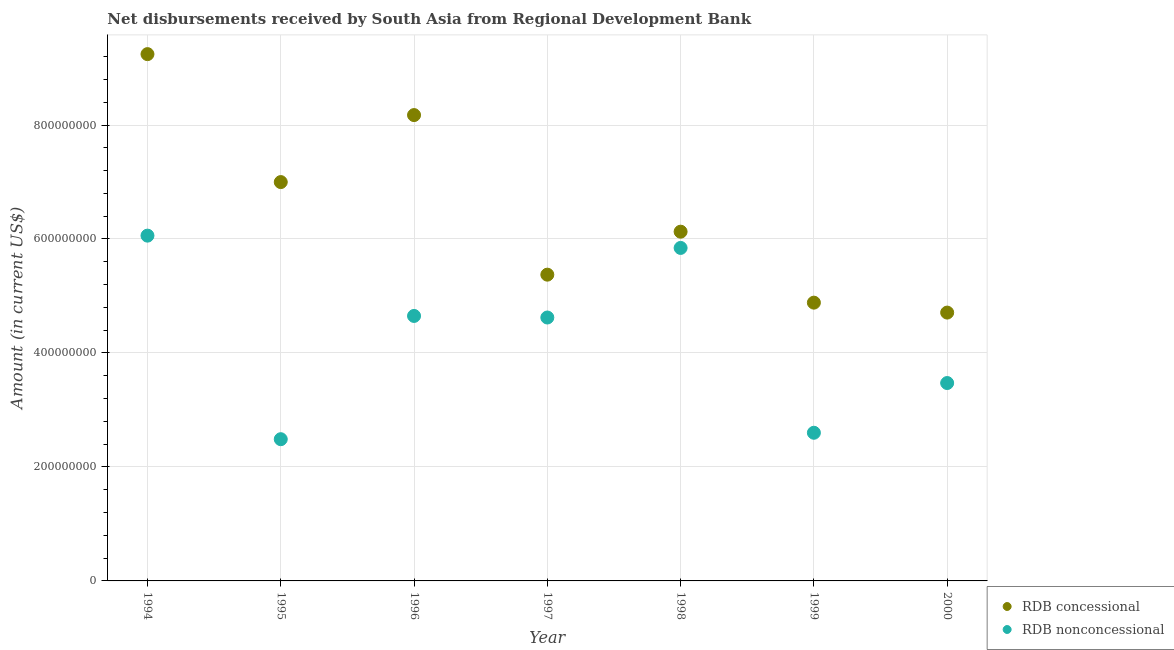How many different coloured dotlines are there?
Ensure brevity in your answer.  2. Is the number of dotlines equal to the number of legend labels?
Make the answer very short. Yes. What is the net non concessional disbursements from rdb in 1999?
Give a very brief answer. 2.60e+08. Across all years, what is the maximum net non concessional disbursements from rdb?
Your response must be concise. 6.06e+08. Across all years, what is the minimum net non concessional disbursements from rdb?
Your response must be concise. 2.49e+08. In which year was the net concessional disbursements from rdb minimum?
Offer a very short reply. 2000. What is the total net non concessional disbursements from rdb in the graph?
Ensure brevity in your answer.  2.97e+09. What is the difference between the net concessional disbursements from rdb in 1994 and that in 1995?
Offer a terse response. 2.25e+08. What is the difference between the net concessional disbursements from rdb in 1997 and the net non concessional disbursements from rdb in 1998?
Ensure brevity in your answer.  -4.69e+07. What is the average net concessional disbursements from rdb per year?
Give a very brief answer. 6.50e+08. In the year 2000, what is the difference between the net concessional disbursements from rdb and net non concessional disbursements from rdb?
Provide a succinct answer. 1.24e+08. In how many years, is the net non concessional disbursements from rdb greater than 80000000 US$?
Offer a very short reply. 7. What is the ratio of the net non concessional disbursements from rdb in 1994 to that in 1995?
Keep it short and to the point. 2.44. What is the difference between the highest and the second highest net concessional disbursements from rdb?
Provide a short and direct response. 1.07e+08. What is the difference between the highest and the lowest net concessional disbursements from rdb?
Offer a very short reply. 4.54e+08. In how many years, is the net non concessional disbursements from rdb greater than the average net non concessional disbursements from rdb taken over all years?
Ensure brevity in your answer.  4. Does the net concessional disbursements from rdb monotonically increase over the years?
Your response must be concise. No. What is the difference between two consecutive major ticks on the Y-axis?
Make the answer very short. 2.00e+08. Does the graph contain grids?
Ensure brevity in your answer.  Yes. How are the legend labels stacked?
Ensure brevity in your answer.  Vertical. What is the title of the graph?
Provide a short and direct response. Net disbursements received by South Asia from Regional Development Bank. What is the label or title of the X-axis?
Your answer should be very brief. Year. What is the label or title of the Y-axis?
Keep it short and to the point. Amount (in current US$). What is the Amount (in current US$) in RDB concessional in 1994?
Ensure brevity in your answer.  9.24e+08. What is the Amount (in current US$) of RDB nonconcessional in 1994?
Offer a terse response. 6.06e+08. What is the Amount (in current US$) in RDB concessional in 1995?
Your answer should be very brief. 7.00e+08. What is the Amount (in current US$) of RDB nonconcessional in 1995?
Give a very brief answer. 2.49e+08. What is the Amount (in current US$) in RDB concessional in 1996?
Your response must be concise. 8.17e+08. What is the Amount (in current US$) of RDB nonconcessional in 1996?
Keep it short and to the point. 4.65e+08. What is the Amount (in current US$) of RDB concessional in 1997?
Keep it short and to the point. 5.37e+08. What is the Amount (in current US$) in RDB nonconcessional in 1997?
Provide a short and direct response. 4.62e+08. What is the Amount (in current US$) of RDB concessional in 1998?
Your answer should be very brief. 6.13e+08. What is the Amount (in current US$) in RDB nonconcessional in 1998?
Ensure brevity in your answer.  5.84e+08. What is the Amount (in current US$) in RDB concessional in 1999?
Ensure brevity in your answer.  4.88e+08. What is the Amount (in current US$) of RDB nonconcessional in 1999?
Your answer should be very brief. 2.60e+08. What is the Amount (in current US$) in RDB concessional in 2000?
Give a very brief answer. 4.71e+08. What is the Amount (in current US$) of RDB nonconcessional in 2000?
Offer a very short reply. 3.47e+08. Across all years, what is the maximum Amount (in current US$) of RDB concessional?
Provide a succinct answer. 9.24e+08. Across all years, what is the maximum Amount (in current US$) of RDB nonconcessional?
Provide a short and direct response. 6.06e+08. Across all years, what is the minimum Amount (in current US$) in RDB concessional?
Your answer should be compact. 4.71e+08. Across all years, what is the minimum Amount (in current US$) in RDB nonconcessional?
Offer a very short reply. 2.49e+08. What is the total Amount (in current US$) of RDB concessional in the graph?
Offer a terse response. 4.55e+09. What is the total Amount (in current US$) in RDB nonconcessional in the graph?
Offer a very short reply. 2.97e+09. What is the difference between the Amount (in current US$) in RDB concessional in 1994 and that in 1995?
Your response must be concise. 2.25e+08. What is the difference between the Amount (in current US$) in RDB nonconcessional in 1994 and that in 1995?
Make the answer very short. 3.57e+08. What is the difference between the Amount (in current US$) in RDB concessional in 1994 and that in 1996?
Provide a short and direct response. 1.07e+08. What is the difference between the Amount (in current US$) of RDB nonconcessional in 1994 and that in 1996?
Offer a terse response. 1.41e+08. What is the difference between the Amount (in current US$) of RDB concessional in 1994 and that in 1997?
Ensure brevity in your answer.  3.87e+08. What is the difference between the Amount (in current US$) in RDB nonconcessional in 1994 and that in 1997?
Offer a very short reply. 1.44e+08. What is the difference between the Amount (in current US$) in RDB concessional in 1994 and that in 1998?
Your answer should be very brief. 3.12e+08. What is the difference between the Amount (in current US$) in RDB nonconcessional in 1994 and that in 1998?
Your answer should be very brief. 2.16e+07. What is the difference between the Amount (in current US$) in RDB concessional in 1994 and that in 1999?
Your answer should be very brief. 4.36e+08. What is the difference between the Amount (in current US$) of RDB nonconcessional in 1994 and that in 1999?
Provide a succinct answer. 3.46e+08. What is the difference between the Amount (in current US$) in RDB concessional in 1994 and that in 2000?
Your response must be concise. 4.54e+08. What is the difference between the Amount (in current US$) in RDB nonconcessional in 1994 and that in 2000?
Offer a terse response. 2.59e+08. What is the difference between the Amount (in current US$) in RDB concessional in 1995 and that in 1996?
Ensure brevity in your answer.  -1.18e+08. What is the difference between the Amount (in current US$) of RDB nonconcessional in 1995 and that in 1996?
Keep it short and to the point. -2.16e+08. What is the difference between the Amount (in current US$) in RDB concessional in 1995 and that in 1997?
Offer a very short reply. 1.62e+08. What is the difference between the Amount (in current US$) in RDB nonconcessional in 1995 and that in 1997?
Give a very brief answer. -2.14e+08. What is the difference between the Amount (in current US$) in RDB concessional in 1995 and that in 1998?
Your response must be concise. 8.70e+07. What is the difference between the Amount (in current US$) of RDB nonconcessional in 1995 and that in 1998?
Make the answer very short. -3.36e+08. What is the difference between the Amount (in current US$) of RDB concessional in 1995 and that in 1999?
Give a very brief answer. 2.12e+08. What is the difference between the Amount (in current US$) in RDB nonconcessional in 1995 and that in 1999?
Provide a succinct answer. -1.13e+07. What is the difference between the Amount (in current US$) in RDB concessional in 1995 and that in 2000?
Offer a very short reply. 2.29e+08. What is the difference between the Amount (in current US$) of RDB nonconcessional in 1995 and that in 2000?
Your answer should be compact. -9.86e+07. What is the difference between the Amount (in current US$) of RDB concessional in 1996 and that in 1997?
Provide a short and direct response. 2.80e+08. What is the difference between the Amount (in current US$) of RDB nonconcessional in 1996 and that in 1997?
Keep it short and to the point. 2.76e+06. What is the difference between the Amount (in current US$) in RDB concessional in 1996 and that in 1998?
Your answer should be compact. 2.05e+08. What is the difference between the Amount (in current US$) of RDB nonconcessional in 1996 and that in 1998?
Your answer should be very brief. -1.19e+08. What is the difference between the Amount (in current US$) of RDB concessional in 1996 and that in 1999?
Your response must be concise. 3.29e+08. What is the difference between the Amount (in current US$) in RDB nonconcessional in 1996 and that in 1999?
Keep it short and to the point. 2.05e+08. What is the difference between the Amount (in current US$) of RDB concessional in 1996 and that in 2000?
Ensure brevity in your answer.  3.47e+08. What is the difference between the Amount (in current US$) in RDB nonconcessional in 1996 and that in 2000?
Make the answer very short. 1.18e+08. What is the difference between the Amount (in current US$) in RDB concessional in 1997 and that in 1998?
Your answer should be very brief. -7.54e+07. What is the difference between the Amount (in current US$) in RDB nonconcessional in 1997 and that in 1998?
Give a very brief answer. -1.22e+08. What is the difference between the Amount (in current US$) in RDB concessional in 1997 and that in 1999?
Offer a terse response. 4.91e+07. What is the difference between the Amount (in current US$) in RDB nonconcessional in 1997 and that in 1999?
Your answer should be very brief. 2.02e+08. What is the difference between the Amount (in current US$) of RDB concessional in 1997 and that in 2000?
Offer a very short reply. 6.66e+07. What is the difference between the Amount (in current US$) in RDB nonconcessional in 1997 and that in 2000?
Your response must be concise. 1.15e+08. What is the difference between the Amount (in current US$) in RDB concessional in 1998 and that in 1999?
Your answer should be very brief. 1.25e+08. What is the difference between the Amount (in current US$) of RDB nonconcessional in 1998 and that in 1999?
Provide a succinct answer. 3.24e+08. What is the difference between the Amount (in current US$) of RDB concessional in 1998 and that in 2000?
Provide a succinct answer. 1.42e+08. What is the difference between the Amount (in current US$) of RDB nonconcessional in 1998 and that in 2000?
Offer a terse response. 2.37e+08. What is the difference between the Amount (in current US$) of RDB concessional in 1999 and that in 2000?
Provide a succinct answer. 1.75e+07. What is the difference between the Amount (in current US$) in RDB nonconcessional in 1999 and that in 2000?
Offer a terse response. -8.73e+07. What is the difference between the Amount (in current US$) in RDB concessional in 1994 and the Amount (in current US$) in RDB nonconcessional in 1995?
Your answer should be compact. 6.76e+08. What is the difference between the Amount (in current US$) of RDB concessional in 1994 and the Amount (in current US$) of RDB nonconcessional in 1996?
Provide a succinct answer. 4.59e+08. What is the difference between the Amount (in current US$) of RDB concessional in 1994 and the Amount (in current US$) of RDB nonconcessional in 1997?
Ensure brevity in your answer.  4.62e+08. What is the difference between the Amount (in current US$) of RDB concessional in 1994 and the Amount (in current US$) of RDB nonconcessional in 1998?
Give a very brief answer. 3.40e+08. What is the difference between the Amount (in current US$) in RDB concessional in 1994 and the Amount (in current US$) in RDB nonconcessional in 1999?
Keep it short and to the point. 6.64e+08. What is the difference between the Amount (in current US$) of RDB concessional in 1994 and the Amount (in current US$) of RDB nonconcessional in 2000?
Make the answer very short. 5.77e+08. What is the difference between the Amount (in current US$) of RDB concessional in 1995 and the Amount (in current US$) of RDB nonconcessional in 1996?
Give a very brief answer. 2.35e+08. What is the difference between the Amount (in current US$) of RDB concessional in 1995 and the Amount (in current US$) of RDB nonconcessional in 1997?
Offer a very short reply. 2.38e+08. What is the difference between the Amount (in current US$) of RDB concessional in 1995 and the Amount (in current US$) of RDB nonconcessional in 1998?
Make the answer very short. 1.16e+08. What is the difference between the Amount (in current US$) of RDB concessional in 1995 and the Amount (in current US$) of RDB nonconcessional in 1999?
Provide a short and direct response. 4.40e+08. What is the difference between the Amount (in current US$) of RDB concessional in 1995 and the Amount (in current US$) of RDB nonconcessional in 2000?
Offer a terse response. 3.53e+08. What is the difference between the Amount (in current US$) of RDB concessional in 1996 and the Amount (in current US$) of RDB nonconcessional in 1997?
Offer a very short reply. 3.55e+08. What is the difference between the Amount (in current US$) in RDB concessional in 1996 and the Amount (in current US$) in RDB nonconcessional in 1998?
Provide a short and direct response. 2.33e+08. What is the difference between the Amount (in current US$) of RDB concessional in 1996 and the Amount (in current US$) of RDB nonconcessional in 1999?
Give a very brief answer. 5.57e+08. What is the difference between the Amount (in current US$) in RDB concessional in 1996 and the Amount (in current US$) in RDB nonconcessional in 2000?
Make the answer very short. 4.70e+08. What is the difference between the Amount (in current US$) of RDB concessional in 1997 and the Amount (in current US$) of RDB nonconcessional in 1998?
Provide a short and direct response. -4.69e+07. What is the difference between the Amount (in current US$) of RDB concessional in 1997 and the Amount (in current US$) of RDB nonconcessional in 1999?
Give a very brief answer. 2.77e+08. What is the difference between the Amount (in current US$) of RDB concessional in 1997 and the Amount (in current US$) of RDB nonconcessional in 2000?
Your response must be concise. 1.90e+08. What is the difference between the Amount (in current US$) in RDB concessional in 1998 and the Amount (in current US$) in RDB nonconcessional in 1999?
Provide a succinct answer. 3.53e+08. What is the difference between the Amount (in current US$) in RDB concessional in 1998 and the Amount (in current US$) in RDB nonconcessional in 2000?
Keep it short and to the point. 2.66e+08. What is the difference between the Amount (in current US$) in RDB concessional in 1999 and the Amount (in current US$) in RDB nonconcessional in 2000?
Ensure brevity in your answer.  1.41e+08. What is the average Amount (in current US$) in RDB concessional per year?
Make the answer very short. 6.50e+08. What is the average Amount (in current US$) in RDB nonconcessional per year?
Ensure brevity in your answer.  4.25e+08. In the year 1994, what is the difference between the Amount (in current US$) in RDB concessional and Amount (in current US$) in RDB nonconcessional?
Provide a short and direct response. 3.19e+08. In the year 1995, what is the difference between the Amount (in current US$) of RDB concessional and Amount (in current US$) of RDB nonconcessional?
Your answer should be compact. 4.51e+08. In the year 1996, what is the difference between the Amount (in current US$) in RDB concessional and Amount (in current US$) in RDB nonconcessional?
Ensure brevity in your answer.  3.52e+08. In the year 1997, what is the difference between the Amount (in current US$) of RDB concessional and Amount (in current US$) of RDB nonconcessional?
Your response must be concise. 7.52e+07. In the year 1998, what is the difference between the Amount (in current US$) in RDB concessional and Amount (in current US$) in RDB nonconcessional?
Provide a short and direct response. 2.85e+07. In the year 1999, what is the difference between the Amount (in current US$) in RDB concessional and Amount (in current US$) in RDB nonconcessional?
Offer a very short reply. 2.28e+08. In the year 2000, what is the difference between the Amount (in current US$) of RDB concessional and Amount (in current US$) of RDB nonconcessional?
Provide a short and direct response. 1.24e+08. What is the ratio of the Amount (in current US$) of RDB concessional in 1994 to that in 1995?
Provide a short and direct response. 1.32. What is the ratio of the Amount (in current US$) of RDB nonconcessional in 1994 to that in 1995?
Provide a succinct answer. 2.44. What is the ratio of the Amount (in current US$) of RDB concessional in 1994 to that in 1996?
Ensure brevity in your answer.  1.13. What is the ratio of the Amount (in current US$) in RDB nonconcessional in 1994 to that in 1996?
Your answer should be very brief. 1.3. What is the ratio of the Amount (in current US$) in RDB concessional in 1994 to that in 1997?
Keep it short and to the point. 1.72. What is the ratio of the Amount (in current US$) in RDB nonconcessional in 1994 to that in 1997?
Make the answer very short. 1.31. What is the ratio of the Amount (in current US$) in RDB concessional in 1994 to that in 1998?
Your answer should be very brief. 1.51. What is the ratio of the Amount (in current US$) of RDB nonconcessional in 1994 to that in 1998?
Give a very brief answer. 1.04. What is the ratio of the Amount (in current US$) in RDB concessional in 1994 to that in 1999?
Your response must be concise. 1.89. What is the ratio of the Amount (in current US$) of RDB nonconcessional in 1994 to that in 1999?
Your answer should be compact. 2.33. What is the ratio of the Amount (in current US$) of RDB concessional in 1994 to that in 2000?
Offer a very short reply. 1.96. What is the ratio of the Amount (in current US$) of RDB nonconcessional in 1994 to that in 2000?
Provide a short and direct response. 1.74. What is the ratio of the Amount (in current US$) of RDB concessional in 1995 to that in 1996?
Your answer should be very brief. 0.86. What is the ratio of the Amount (in current US$) of RDB nonconcessional in 1995 to that in 1996?
Keep it short and to the point. 0.53. What is the ratio of the Amount (in current US$) of RDB concessional in 1995 to that in 1997?
Offer a very short reply. 1.3. What is the ratio of the Amount (in current US$) in RDB nonconcessional in 1995 to that in 1997?
Keep it short and to the point. 0.54. What is the ratio of the Amount (in current US$) in RDB concessional in 1995 to that in 1998?
Keep it short and to the point. 1.14. What is the ratio of the Amount (in current US$) of RDB nonconcessional in 1995 to that in 1998?
Offer a very short reply. 0.43. What is the ratio of the Amount (in current US$) of RDB concessional in 1995 to that in 1999?
Keep it short and to the point. 1.43. What is the ratio of the Amount (in current US$) of RDB nonconcessional in 1995 to that in 1999?
Provide a short and direct response. 0.96. What is the ratio of the Amount (in current US$) in RDB concessional in 1995 to that in 2000?
Provide a short and direct response. 1.49. What is the ratio of the Amount (in current US$) in RDB nonconcessional in 1995 to that in 2000?
Offer a terse response. 0.72. What is the ratio of the Amount (in current US$) of RDB concessional in 1996 to that in 1997?
Offer a very short reply. 1.52. What is the ratio of the Amount (in current US$) in RDB concessional in 1996 to that in 1998?
Provide a short and direct response. 1.33. What is the ratio of the Amount (in current US$) of RDB nonconcessional in 1996 to that in 1998?
Provide a short and direct response. 0.8. What is the ratio of the Amount (in current US$) of RDB concessional in 1996 to that in 1999?
Provide a succinct answer. 1.67. What is the ratio of the Amount (in current US$) in RDB nonconcessional in 1996 to that in 1999?
Keep it short and to the point. 1.79. What is the ratio of the Amount (in current US$) of RDB concessional in 1996 to that in 2000?
Your answer should be compact. 1.74. What is the ratio of the Amount (in current US$) of RDB nonconcessional in 1996 to that in 2000?
Provide a succinct answer. 1.34. What is the ratio of the Amount (in current US$) of RDB concessional in 1997 to that in 1998?
Offer a terse response. 0.88. What is the ratio of the Amount (in current US$) of RDB nonconcessional in 1997 to that in 1998?
Your answer should be very brief. 0.79. What is the ratio of the Amount (in current US$) in RDB concessional in 1997 to that in 1999?
Offer a terse response. 1.1. What is the ratio of the Amount (in current US$) of RDB nonconcessional in 1997 to that in 1999?
Give a very brief answer. 1.78. What is the ratio of the Amount (in current US$) in RDB concessional in 1997 to that in 2000?
Give a very brief answer. 1.14. What is the ratio of the Amount (in current US$) in RDB nonconcessional in 1997 to that in 2000?
Your answer should be very brief. 1.33. What is the ratio of the Amount (in current US$) in RDB concessional in 1998 to that in 1999?
Ensure brevity in your answer.  1.25. What is the ratio of the Amount (in current US$) of RDB nonconcessional in 1998 to that in 1999?
Make the answer very short. 2.25. What is the ratio of the Amount (in current US$) in RDB concessional in 1998 to that in 2000?
Ensure brevity in your answer.  1.3. What is the ratio of the Amount (in current US$) of RDB nonconcessional in 1998 to that in 2000?
Your response must be concise. 1.68. What is the ratio of the Amount (in current US$) of RDB concessional in 1999 to that in 2000?
Provide a short and direct response. 1.04. What is the ratio of the Amount (in current US$) in RDB nonconcessional in 1999 to that in 2000?
Make the answer very short. 0.75. What is the difference between the highest and the second highest Amount (in current US$) of RDB concessional?
Make the answer very short. 1.07e+08. What is the difference between the highest and the second highest Amount (in current US$) of RDB nonconcessional?
Give a very brief answer. 2.16e+07. What is the difference between the highest and the lowest Amount (in current US$) in RDB concessional?
Your response must be concise. 4.54e+08. What is the difference between the highest and the lowest Amount (in current US$) of RDB nonconcessional?
Your response must be concise. 3.57e+08. 